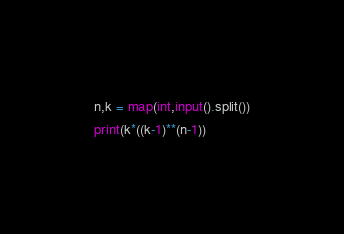Convert code to text. <code><loc_0><loc_0><loc_500><loc_500><_Python_>n,k = map(int,input().split())
print(k*((k-1)**(n-1))</code> 